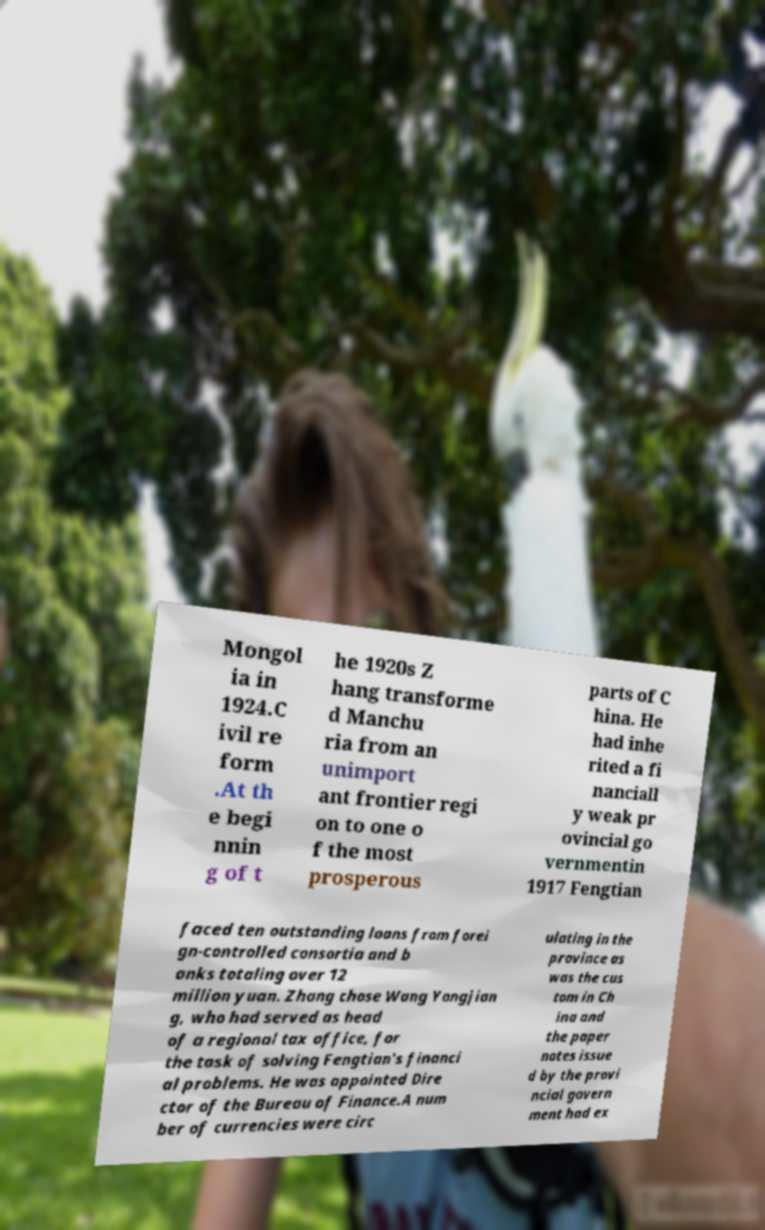Can you read and provide the text displayed in the image?This photo seems to have some interesting text. Can you extract and type it out for me? Mongol ia in 1924.C ivil re form .At th e begi nnin g of t he 1920s Z hang transforme d Manchu ria from an unimport ant frontier regi on to one o f the most prosperous parts of C hina. He had inhe rited a fi nanciall y weak pr ovincial go vernmentin 1917 Fengtian faced ten outstanding loans from forei gn-controlled consortia and b anks totaling over 12 million yuan. Zhang chose Wang Yongjian g, who had served as head of a regional tax office, for the task of solving Fengtian's financi al problems. He was appointed Dire ctor of the Bureau of Finance.A num ber of currencies were circ ulating in the province as was the cus tom in Ch ina and the paper notes issue d by the provi ncial govern ment had ex 